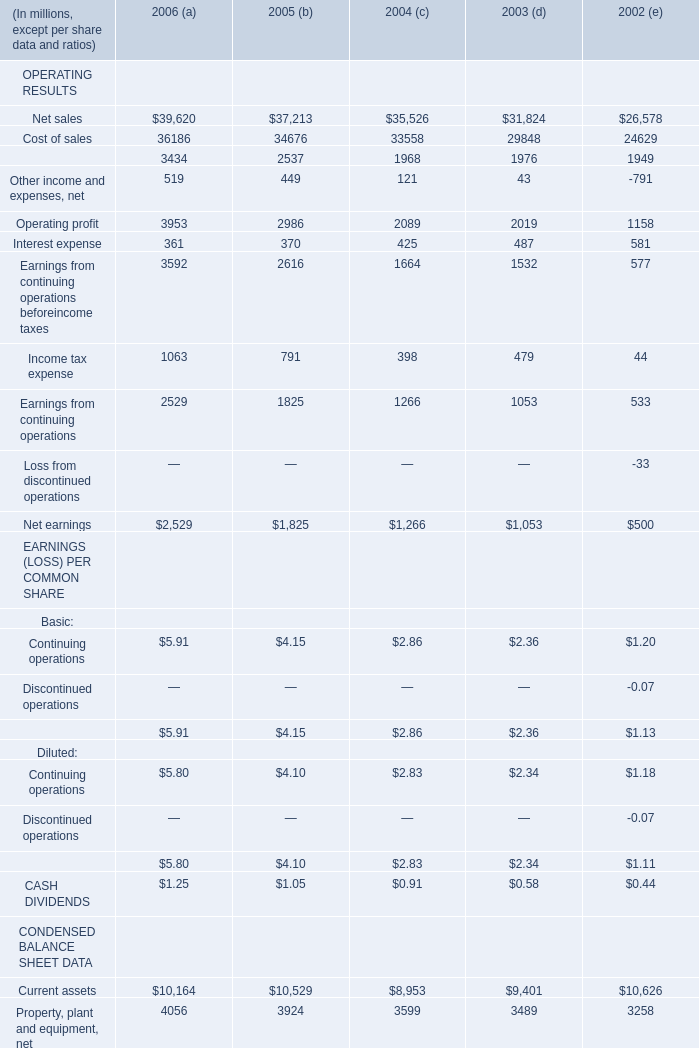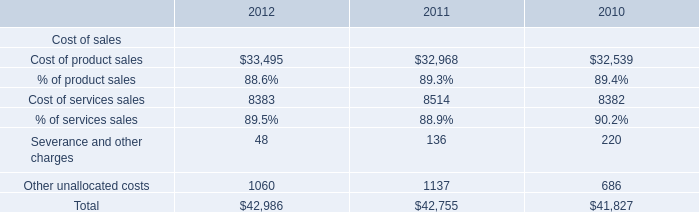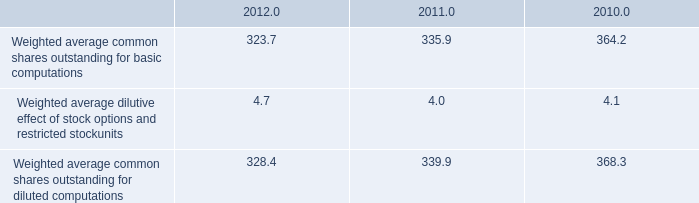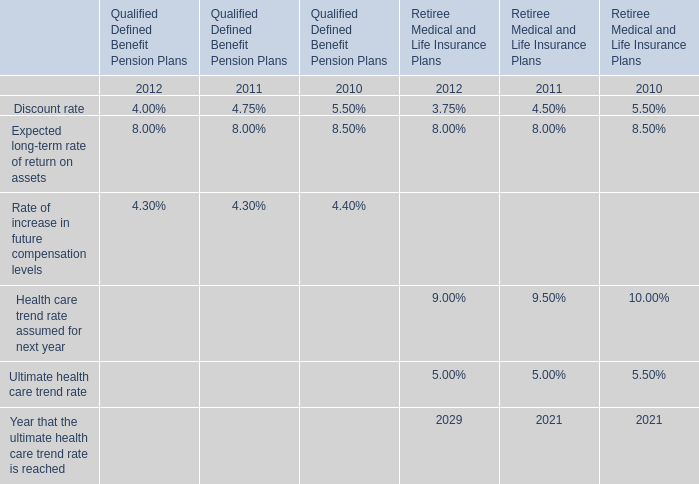What is the difference between the greatest OPERATING RESULTS in 2006 and 2005？ (in million) 
Computations: (39620 - 37213)
Answer: 2407.0. 